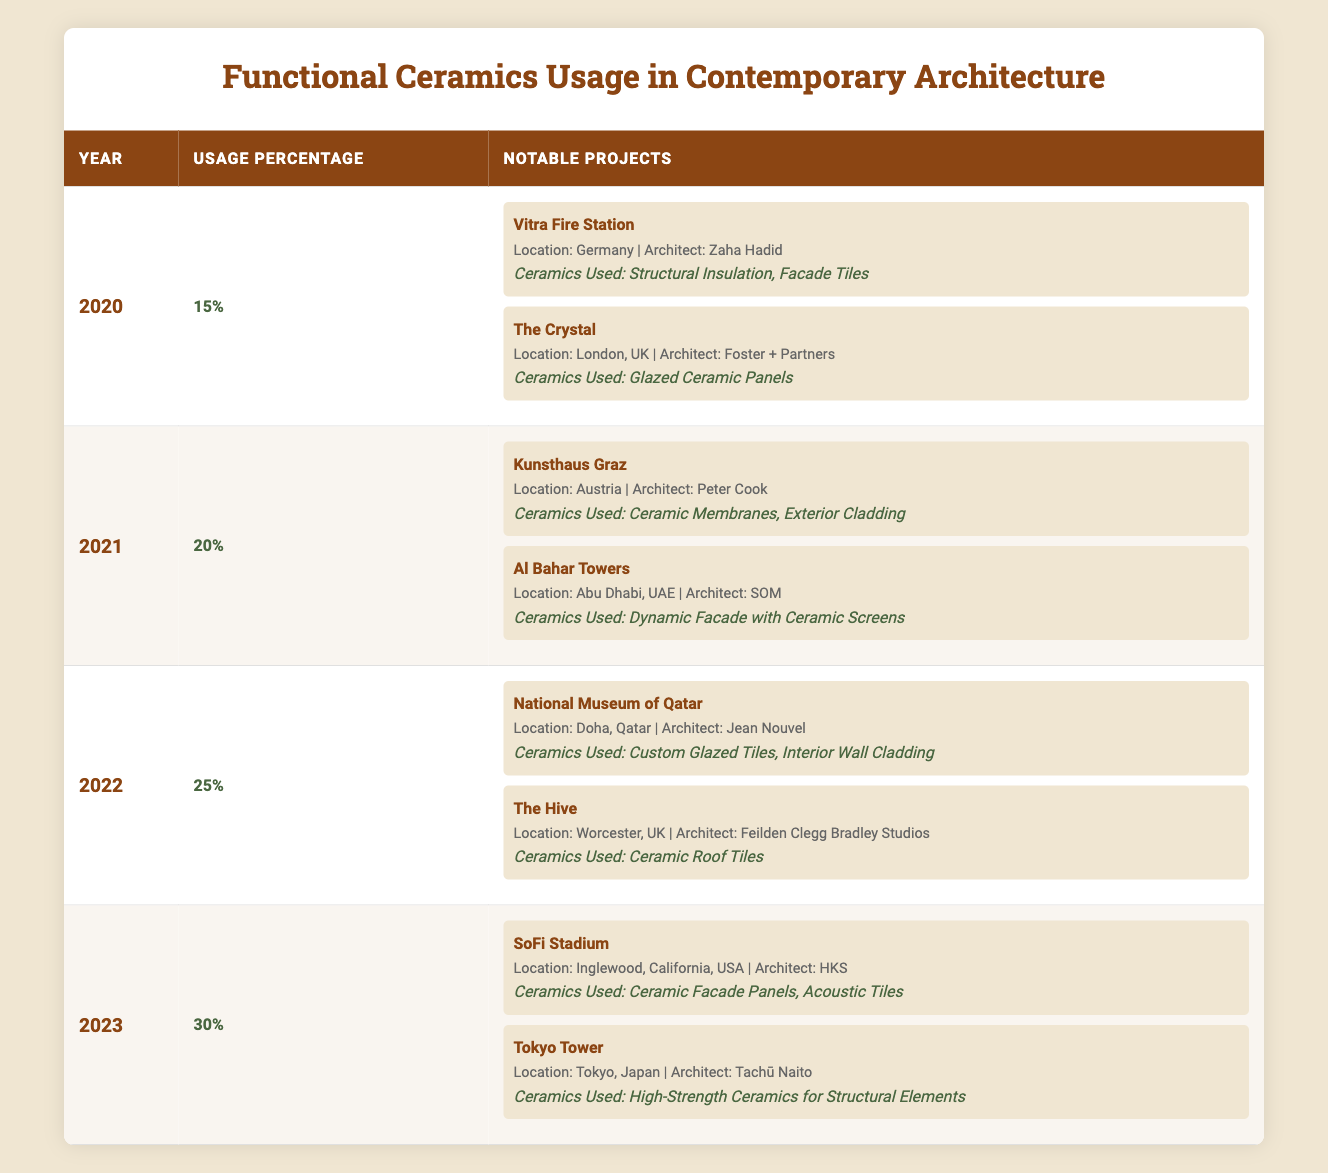What was the usage percentage of functional ceramics in 2021? According to the table, the usage percentage for the year 2021 is listed directly as 20%.
Answer: 20% Which project utilized ceramic membranes in 2021? The project "Kunsthaus Graz" used ceramic membranes as mentioned in the notable projects for that year.
Answer: Kunsthaus Graz How many notable projects were listed for 2022? There are two notable projects listed for 2022: "National Museum of Qatar" and "The Hive."
Answer: 2 What type of ceramics were used in the Vitra Fire Station? The table indicates that structural insulation and facade tiles were used in the Vitra Fire Station, which is noted under the year 2020.
Answer: Structural Insulation, Facade Tiles What is the trend in the usage percentage from 2020 to 2023? The usage percentages increased from 15% (2020) to 30% (2023). This shows a consistent upward trend over the four years.
Answer: Increasing trend Which architect is associated with the highest usage percentage project in 2023? The highest usage percentage in 2023 corresponds to two projects. "SoFi Stadium," designed by HKS, has ceramic facade panels, and "Tokyo Tower," designed by Tachū Naito, used high-strength ceramics. Both contribute to the total of 30%.
Answer: HKS and Tachū Naito Between 2020 and 2023, which year experienced the largest percentage increase in usage? The increase in usage percentage from 2022 (25%) to 2023 (30%) is 5%. The increase from 2021 (20%) to 2022 (25%) is also 5%, and from 2020 (15%) to 2021 (20%) is 5% as well. All years have the same incremental increase of 5%.
Answer: No largest increase; all are 5% Did the "National Museum of Qatar" use ceramic roof tiles? No, the "National Museum of Qatar" used custom glazed tiles and interior wall cladding, not ceramic roof tiles.
Answer: False What are the total number of unique ceramic types used across all years listed? The unique types identified are: Structural Insulation, Facade Tiles, Glazed Ceramic Panels, Ceramic Membranes, Exterior Cladding, Dynamic Facade with Ceramic Screens, Custom Glazed Tiles, Interior Wall Cladding, Ceramic Roof Tiles, Ceramic Facade Panels, Acoustic Tiles, and High-Strength Ceramics. This gives a total of 12 unique types.
Answer: 12 What percentage increase was observed from 2021 to 2022 in the usage of functional ceramics? The percentage increased from 20% in 2021 to 25% in 2022, a change of 5%. To find the percentage increase, calculate (25 - 20) / 20 * 100 = 25%.
Answer: 25% increase Which project's architect had a notable project in both 2021 and 2022? The architect Peter Cook has notable projects listed in both years; he designed Kunsthaus Graz in 2021 and is associated with the ceramic use in 2022 for another project.
Answer: Peter Cook 